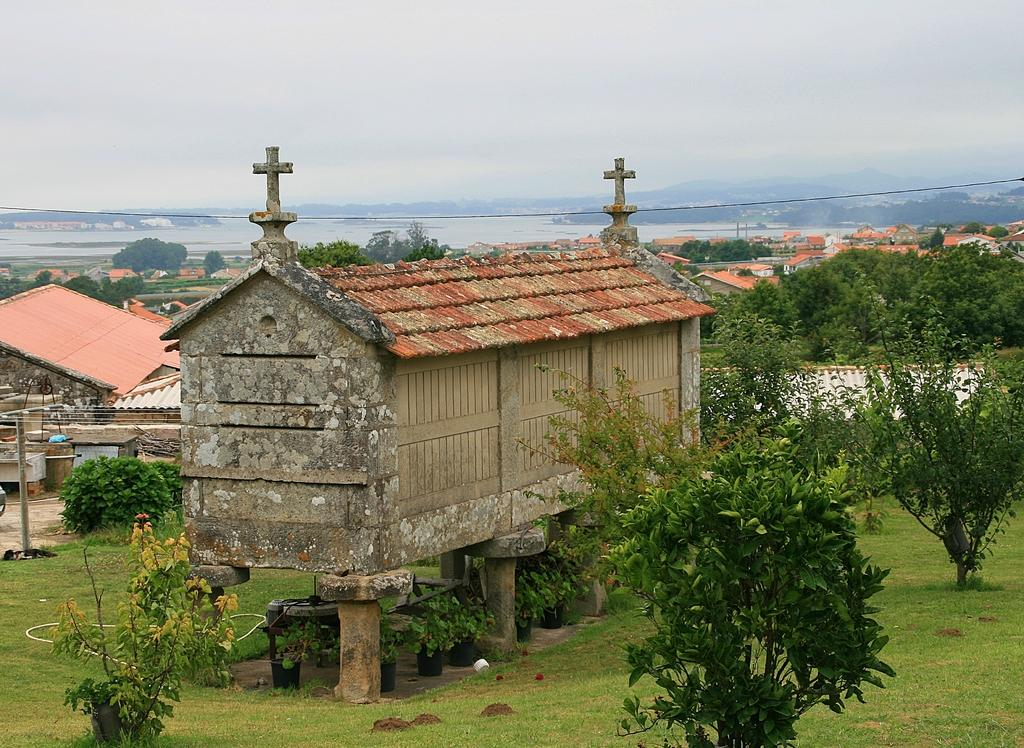What type of vegetation is at the bottom of the image? There is grass at the bottom of the image. What can be seen in the middle of the image? There are trees and houses in the middle of the image. What is visible in the background of the image? There is water visible in the background of the image. What is visible at the top of the image? The sky is visible at the top of the image. What type of pollution can be seen coming from the train in the image? There is no train present in the image, so it is not possible to determine if there is any pollution. What type of toy is visible in the image? There is no toy present in the image. 